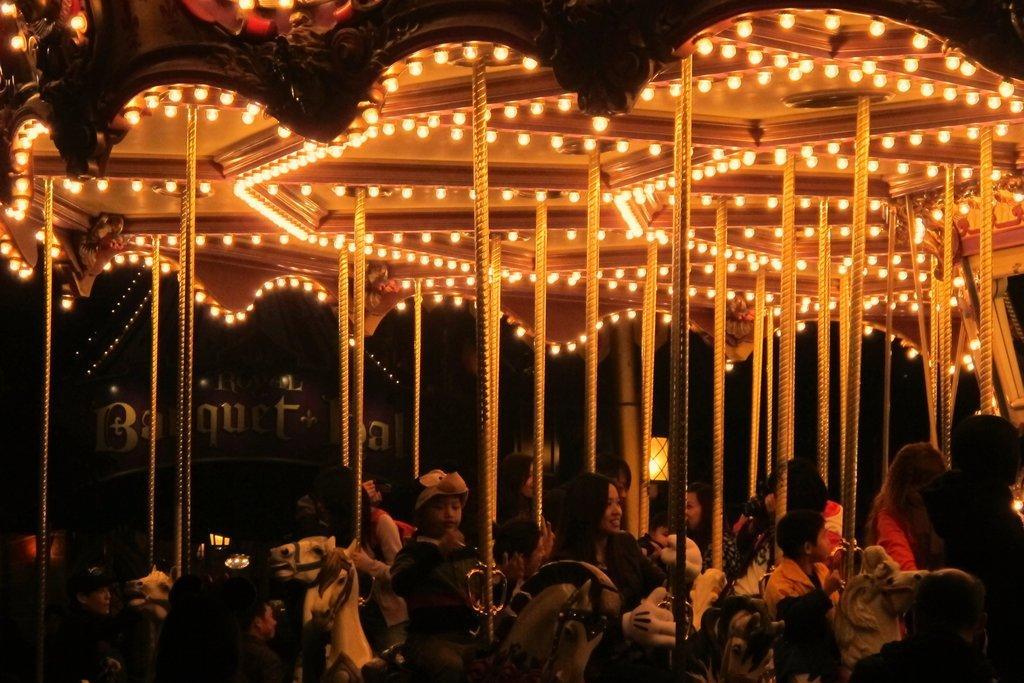How would you summarize this image in a sentence or two? In this image I can see carousel. At the top of it there are some lights. At the bottom there are few children playing on it. This is an image clicked in the dark. 